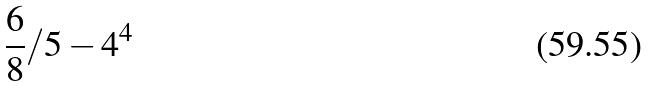<formula> <loc_0><loc_0><loc_500><loc_500>\frac { 6 } { 8 } / 5 - 4 ^ { 4 }</formula> 